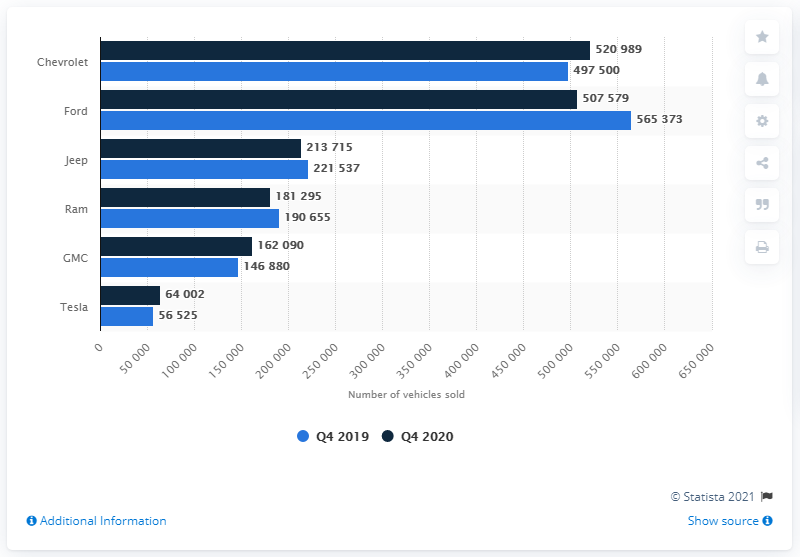Draw attention to some important aspects in this diagram. Chevrolet outsold Ford in car sales during the fourth quarter of 2020. 